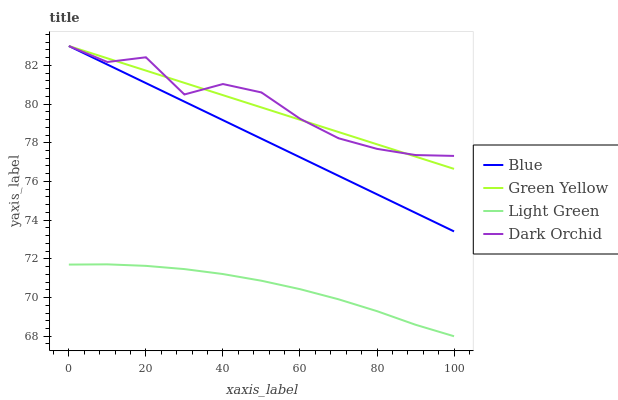Does Light Green have the minimum area under the curve?
Answer yes or no. Yes. Does Dark Orchid have the maximum area under the curve?
Answer yes or no. Yes. Does Green Yellow have the minimum area under the curve?
Answer yes or no. No. Does Green Yellow have the maximum area under the curve?
Answer yes or no. No. Is Blue the smoothest?
Answer yes or no. Yes. Is Dark Orchid the roughest?
Answer yes or no. Yes. Is Green Yellow the smoothest?
Answer yes or no. No. Is Green Yellow the roughest?
Answer yes or no. No. Does Light Green have the lowest value?
Answer yes or no. Yes. Does Green Yellow have the lowest value?
Answer yes or no. No. Does Dark Orchid have the highest value?
Answer yes or no. Yes. Does Light Green have the highest value?
Answer yes or no. No. Is Light Green less than Dark Orchid?
Answer yes or no. Yes. Is Dark Orchid greater than Light Green?
Answer yes or no. Yes. Does Blue intersect Green Yellow?
Answer yes or no. Yes. Is Blue less than Green Yellow?
Answer yes or no. No. Is Blue greater than Green Yellow?
Answer yes or no. No. Does Light Green intersect Dark Orchid?
Answer yes or no. No. 